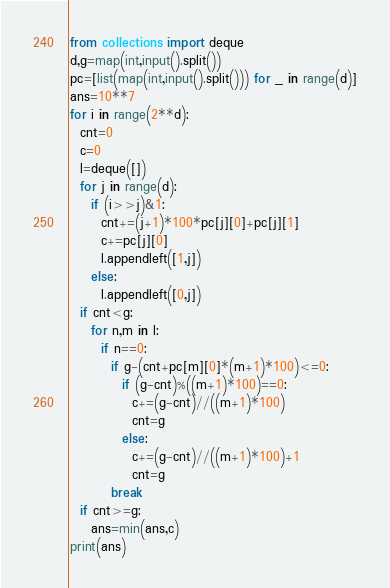Convert code to text. <code><loc_0><loc_0><loc_500><loc_500><_Python_>from collections import deque
d,g=map(int,input().split())
pc=[list(map(int,input().split())) for _ in range(d)]
ans=10**7
for i in range(2**d):
  cnt=0
  c=0
  l=deque([])
  for j in range(d):
    if (i>>j)&1:
      cnt+=(j+1)*100*pc[j][0]+pc[j][1]
      c+=pc[j][0]
      l.appendleft([1,j])
    else:
      l.appendleft([0,j])
  if cnt<g:
    for n,m in l:
      if n==0:
        if g-(cnt+pc[m][0]*(m+1)*100)<=0:
          if (g-cnt)%((m+1)*100)==0:     
            c+=(g-cnt)//((m+1)*100)
            cnt=g
          else:
            c+=(g-cnt)//((m+1)*100)+1
            cnt=g
        break
  if cnt>=g:
    ans=min(ans,c)
print(ans)</code> 